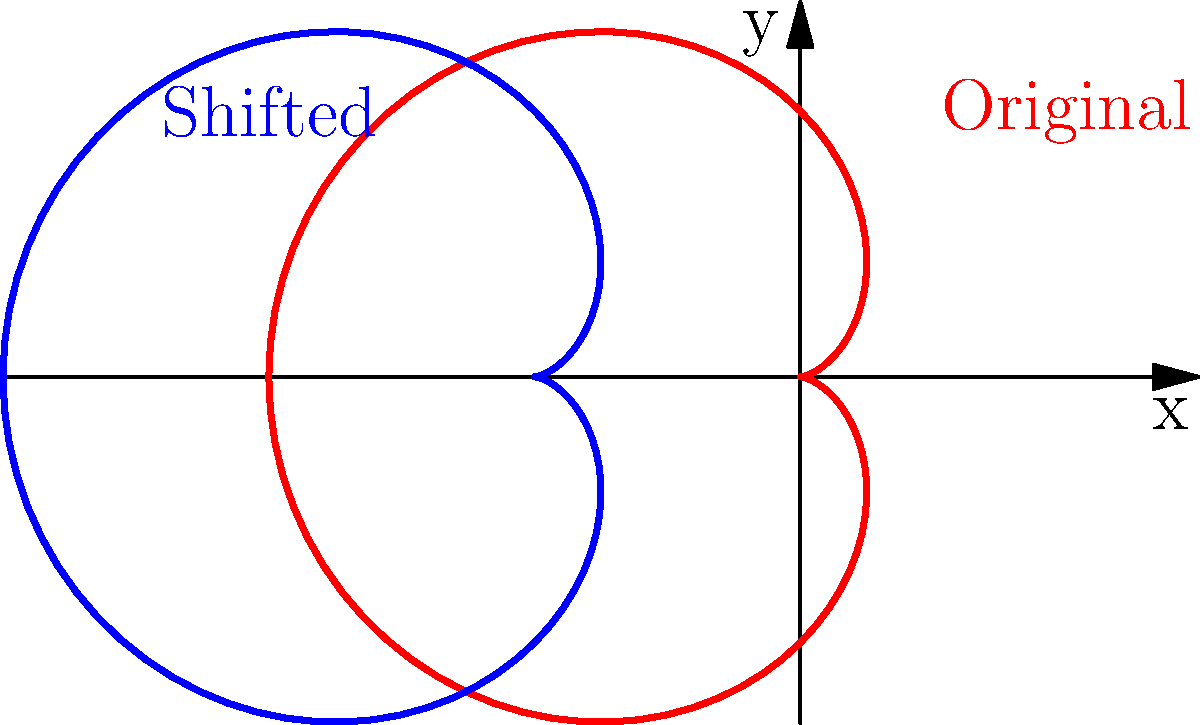In your quest for artistic vengeance, you encounter a cardioid shape symbolizing a broken heart. The original cardioid is given by the polar equation $r = 2(1 - \cos\theta)$. If you were to shift this cardioid 2 units to the left to represent your journey of healing, what would be the new Cartesian equation of the shifted cardioid? To solve this problem, let's follow these steps:

1) The original cardioid equation in polar form is:
   $r = 2(1 - \cos\theta)$

2) Convert the polar equation to Cartesian form:
   $x = r\cos\theta$ and $y = r\sin\theta$
   Substitute $r$:
   $x = 2(1 - \cos\theta)\cos\theta$ and $y = 2(1 - \cos\theta)\sin\theta$

3) Simplify:
   $x = 2\cos\theta - 2\cos^2\theta$ and $y = 2\sin\theta - 2\sin\theta\cos\theta$

4) Use the identity $\cos^2\theta = \frac{1}{2}(1 + \cos2\theta)$:
   $x = 2\cos\theta - (1 + \cos2\theta) = \cos\theta - \cos2\theta - 1$

5) Use the double angle formula $\cos2\theta = 2\cos^2\theta - 1$:
   $x = \cos\theta - (2\cos^2\theta - 1) - 1 = \cos\theta - 2\cos^2\theta$

6) Square both sides of $x = \cos\theta - 2\cos^2\theta$ and $y = 2\sin\theta - 2\sin\theta\cos\theta$:
   $x^2 = \cos^2\theta - 4\cos^3\theta + 4\cos^4\theta$
   $y^2 = 4\sin^2\theta - 8\sin^2\theta\cos\theta + 4\sin^2\theta\cos^2\theta$

7) Add $x^2$ and $y^2$:
   $x^2 + y^2 = \cos^2\theta + \sin^2\theta - 4\cos^3\theta + 4\cos^4\theta + 4\sin^2\theta - 8\sin^2\theta\cos\theta + 4\sin^2\theta\cos^2\theta$

8) Simplify using $\cos^2\theta + \sin^2\theta = 1$:
   $x^2 + y^2 = 1 - 4\cos^3\theta + 4\cos^4\theta + 4 - 8\sin^2\theta\cos\theta + 4\sin^2\theta\cos^2\theta$
   $x^2 + y^2 = 5 - 4\cos^3\theta + 4\cos^4\theta - 8\sin^2\theta\cos\theta + 4\sin^2\theta\cos^2\theta$

9) Use $x = \cos\theta - 2\cos^2\theta$ to substitute for $\cos\theta$:
   $\cos\theta = x + 2\cos^2\theta$
   $\cos^2\theta = \frac{1}{4}(1 - x)$

10) Substitute these into the equation from step 8:
    $x^2 + y^2 = 5 - 4(x + \frac{1}{2}(1-x))^3 + 4(\frac{1}{4}(1-x))^2 - 8(1-\frac{1}{4}(1-x)^2)(x + \frac{1}{2}(1-x)) + 4(1-\frac{1}{4}(1-x)^2)(\frac{1}{4}(1-x))$

11) Simplify (this is a lengthy process):
    $x^2 + y^2 = 4x + 4$

12) To shift the cardioid 2 units to the left, replace x with (x+2):
    $(x+2)^2 + y^2 = 4(x+2) + 4$

13) Expand:
    $x^2 + 4x + 4 + y^2 = 4x + 8 + 4$

14) Simplify:
    $x^2 + y^2 = 8$

This is the Cartesian equation of the shifted cardioid.
Answer: $x^2 + y^2 = 8$ 